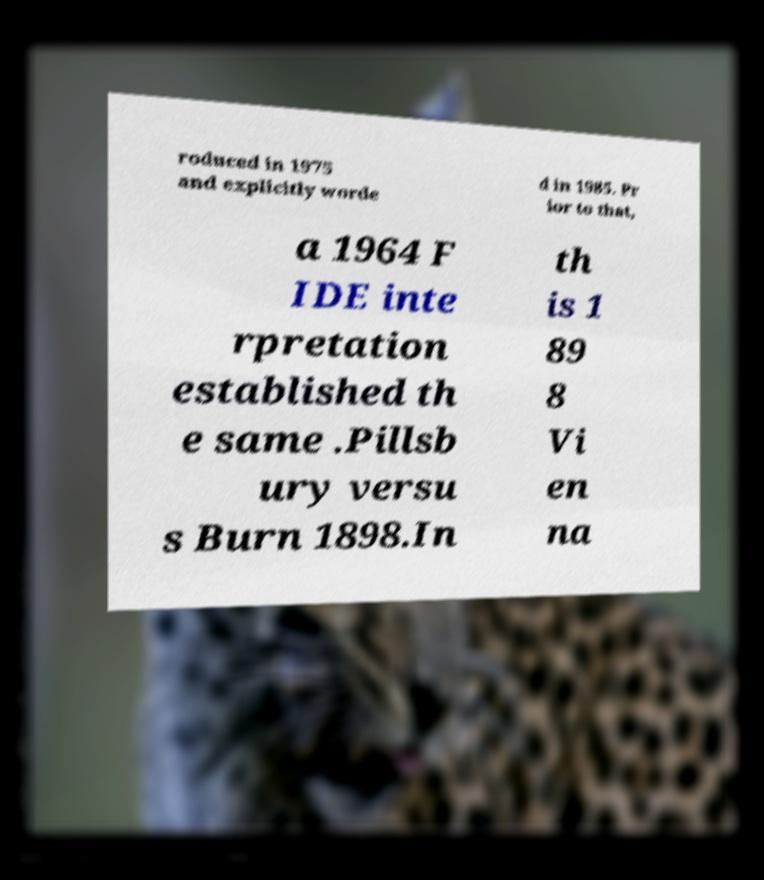For documentation purposes, I need the text within this image transcribed. Could you provide that? roduced in 1975 and explicitly worde d in 1985. Pr ior to that, a 1964 F IDE inte rpretation established th e same .Pillsb ury versu s Burn 1898.In th is 1 89 8 Vi en na 